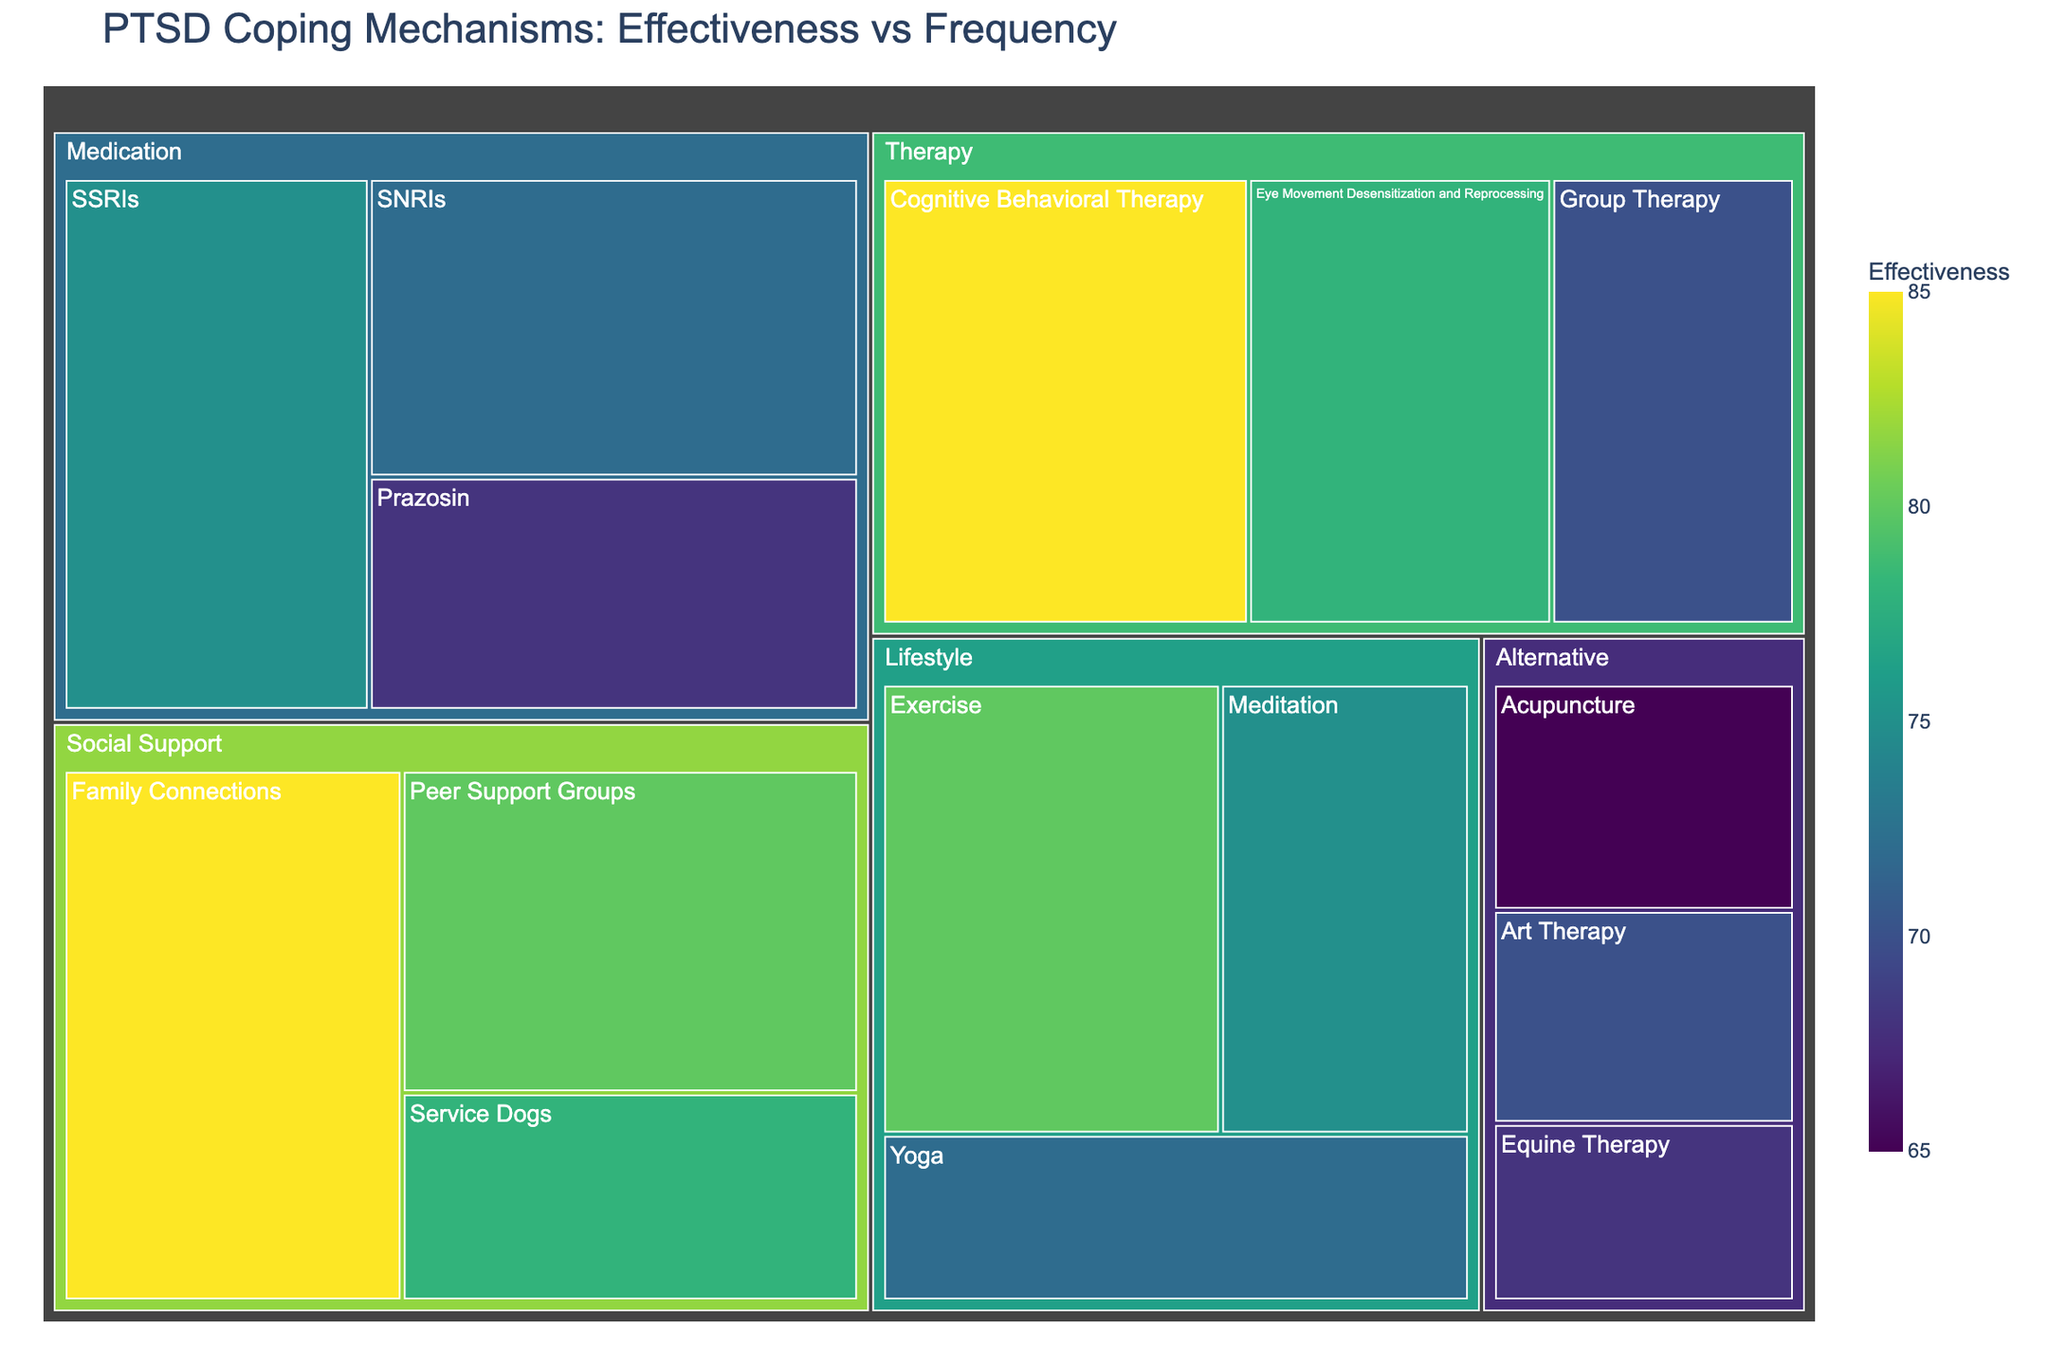What is the effectiveness of Cognitive Behavioral Therapy? The treemap directly shows the effectiveness of each coping mechanism. Locate Cognitive Behavioral Therapy within the Therapy category, where its effectiveness is displayed.
Answer: 85 Which coping mechanism has the highest frequency of use? The figure shows the frequency data in hover information. SSRIs have the highest frequency, which can be seen when hovering over its section in the Medication category.
Answer: SSRIs What is the size of the section representing Family Connections? The size is calculated by multiplying effectiveness and frequency. For Family Connections, this would be 85 (effectiveness) * 78 (frequency).
Answer: 6630 Among the lifestyle mechanisms, which one has the highest effectiveness? The treemap categorizes mechanisms into sections. Within the Lifestyle category, locate the mechanism with the highest effectiveness value by visually comparing.
Answer: Exercise Which category has the most mechanisms? To find this, count the number of coping mechanisms under each category based on the figure's layout.
Answer: Therapy What is the combined effectiveness of Group Therapy and Meditation? Add the effectiveness values: Group Therapy (70) + Meditation (75). Perform the addition.
Answer: 145 Which mechanism in the Alternative category has the highest frequency? Navigate to the Alternative category in the treemap and compare the frequency values listed for each mechanism.
Answer: Acupuncture How does the size of Cognitive Behavioral Therapy compare to Eye Movement Desensitization and Reprocessing? Calculate the size of both: CBT (85 * 72 = 6120) and EMDR (78 * 65 = 5070). Compare these values.
Answer: CBT is larger What is the average effectiveness of the Medication category? Add the effectiveness values for all mechanisms listed under Medication: (75 + 72 + 68) and divide by the number of mechanisms (3).
Answer: 71.67 Which category exhibits the widest range in effectiveness? For each category, subtract the minimum effectiveness from the maximum. Compare the ranges across categories. Maximum range is found in the earned category.
Answer: Therapy 